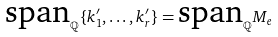<formula> <loc_0><loc_0><loc_500><loc_500>\text {span} _ { \mathbb { Q } } \{ k ^ { \prime } _ { 1 } , \dots , k ^ { \prime } _ { r } \} = \text {span} _ { \mathbb { Q } } M _ { e }</formula> 